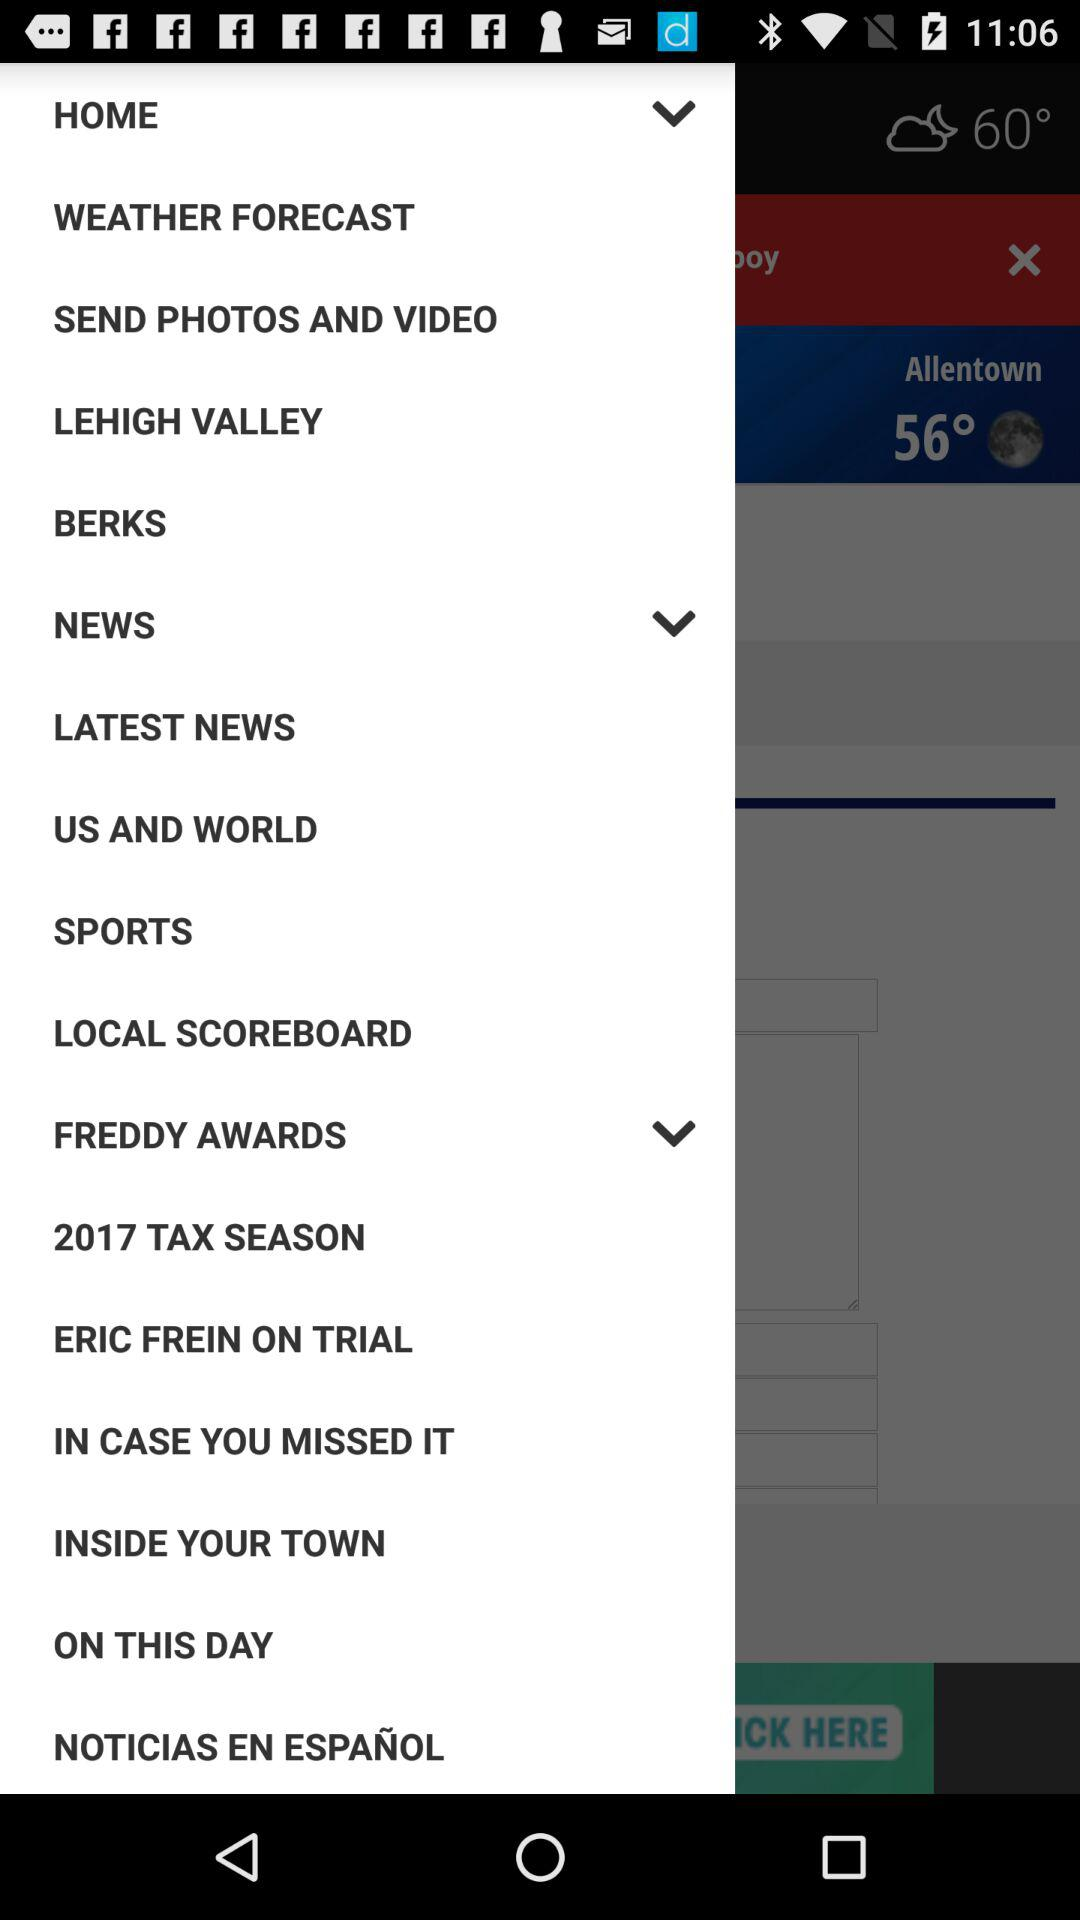Which item is selected in the list?
When the provided information is insufficient, respond with <no answer>. <no answer> 